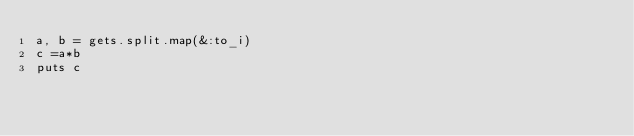<code> <loc_0><loc_0><loc_500><loc_500><_Ruby_>a, b = gets.split.map(&:to_i)
c =a*b
puts c</code> 